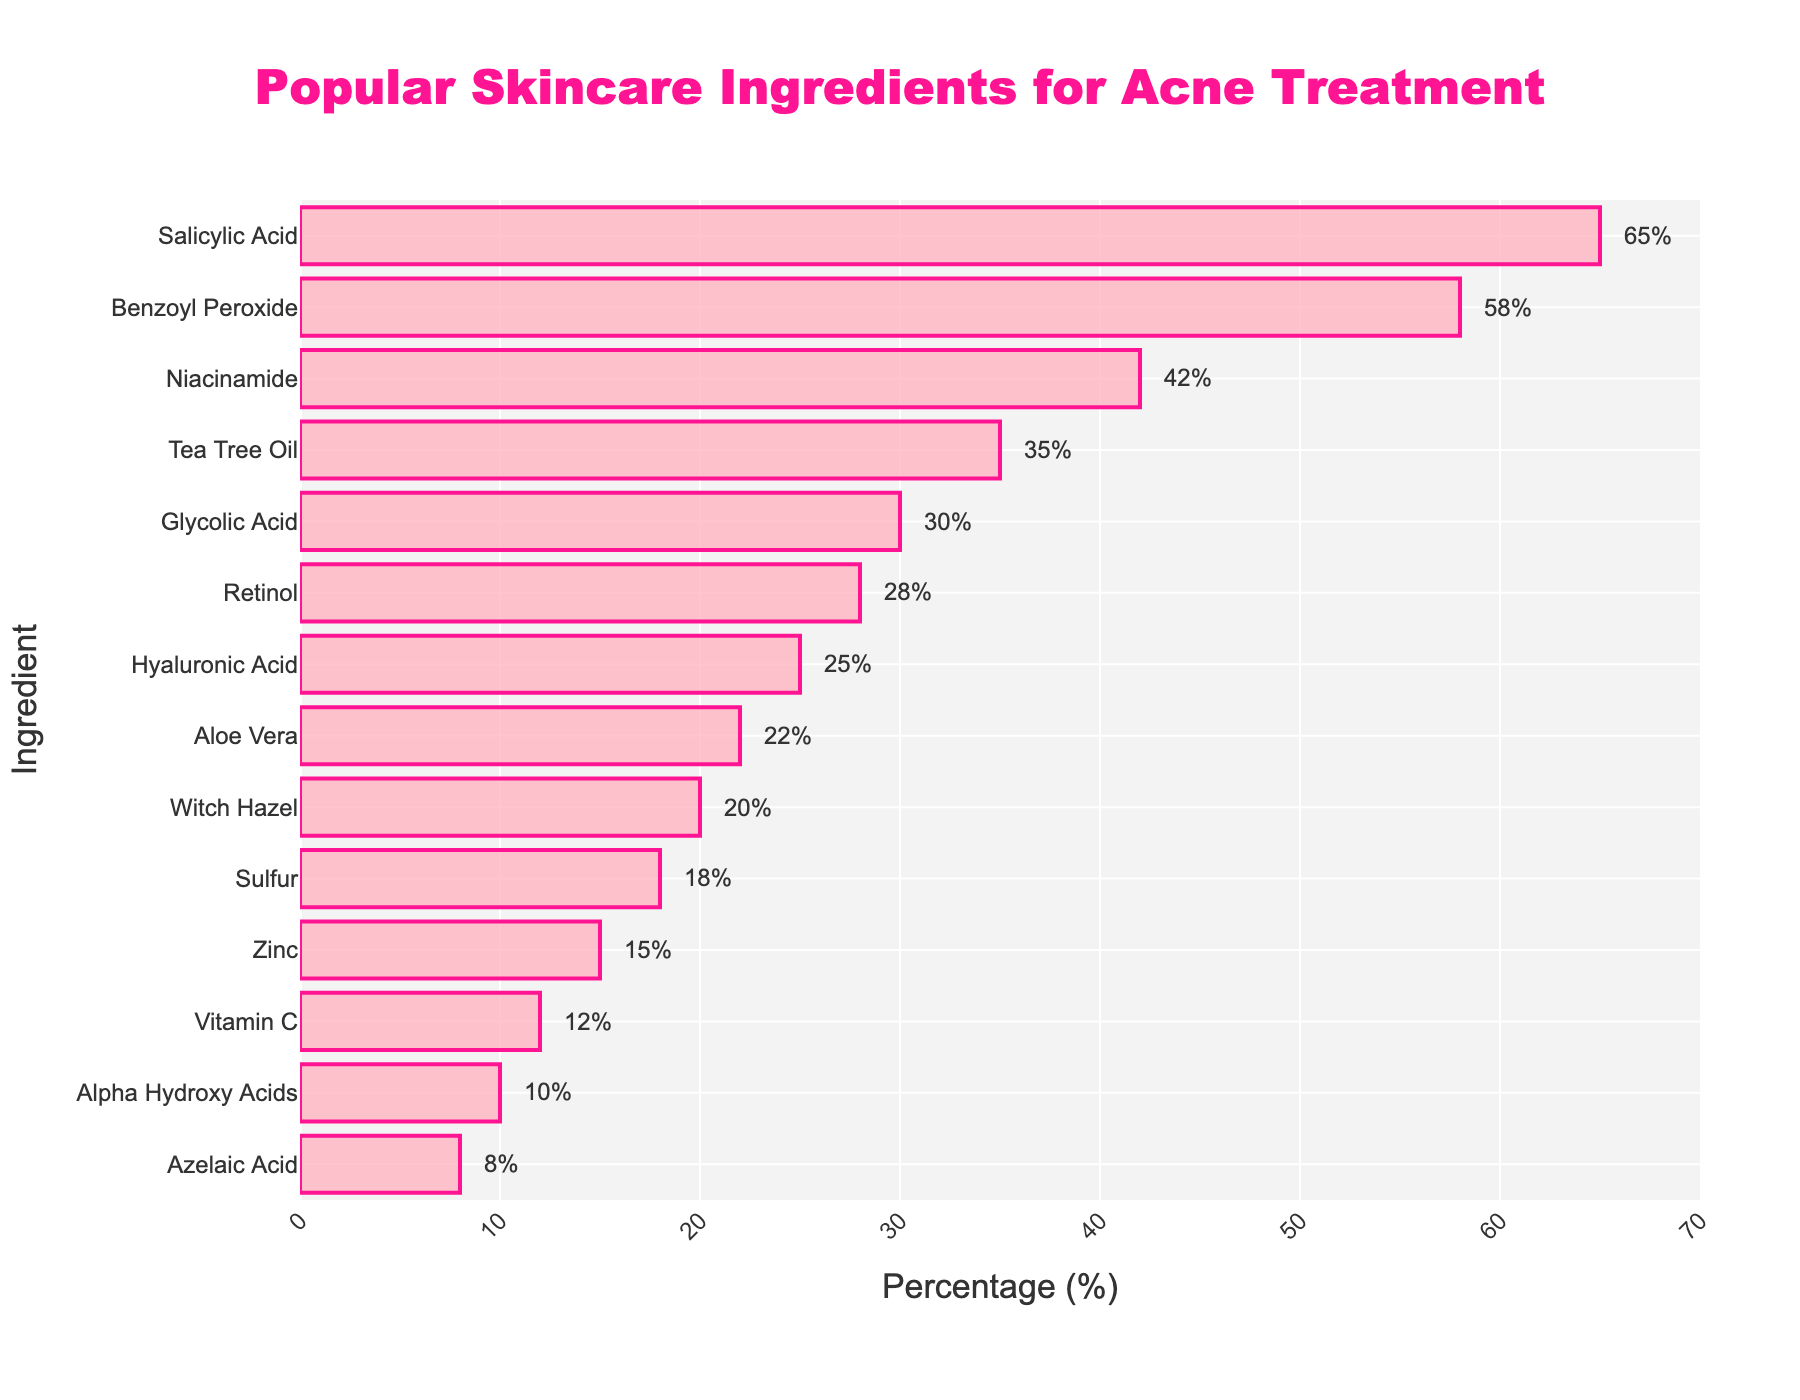Which ingredient is found in the highest percentage in acne products? Look at the bar for each ingredient and identify which bar is the longest. The longest bar represents Salicylic Acid at 65%.
Answer: Salicylic Acid What is the difference in percentage between Benzoyl Peroxide and Tea Tree Oil? Find the percentage for Benzoyl Peroxide (58%) and Tea Tree Oil (35%) and subtract the smaller value from the larger value: 58% - 35% = 23%.
Answer: 23% How many ingredients have a percentage greater than 30%? Count all the bars that extend past the 30% mark: Salicylic Acid, Benzoyl Peroxide, Niacinamide, Tea Tree Oil, and Glycolic Acid. There are 5 such ingredients.
Answer: 5 If you combine the percentages of Retinol and Hyaluronic Acid, what is the total? Add the percentage of Retinol (28%) and Hyaluronic Acid (25%): 28% + 25% = 53%.
Answer: 53% Which ingredients are represented with a percentage less than 20%? Look for the bars that do not extend past the 20% mark: Sulfur (18%), Zinc (15%), Vitamin C (12%), Alpha Hydroxy Acids (10%), and Azelaic Acid (8%).
Answer: Sulfur, Zinc, Vitamin C, Alpha Hydroxy Acids, Azelaic Acid Is Aloe Vera more or less common than Witch Hazel in acne products? Compare the lengths of the bars for Aloe Vera and Witch Hazel. Aloe Vera has a longer bar at 22% compared to Witch Hazel at 20%.
Answer: More common Of the ingredients listed, which has the shortest bar? Identify the smallest bar length visually. Azelaic Acid has the shortest bar, representing 8%.
Answer: Azelaic Acid What is the average percentage of the top 3 most common ingredients? Find the top 3 ingredients by percentage (Salicylic Acid, Benzoyl Peroxide, Niacinamide) and calculate the average: (65% + 58% + 42%) / 3 = 165 / 3 = 55%.
Answer: 55% If you look only at the natural ingredients (Tea Tree Oil, Aloe Vera, Witch Hazel), which one appears the least? Compare the bars of Tea Tree Oil (35%), Aloe Vera (22%), Witch Hazel (20%) and see which is the shortest. Witch Hazel is the least at 20%.
Answer: Witch Hazel 